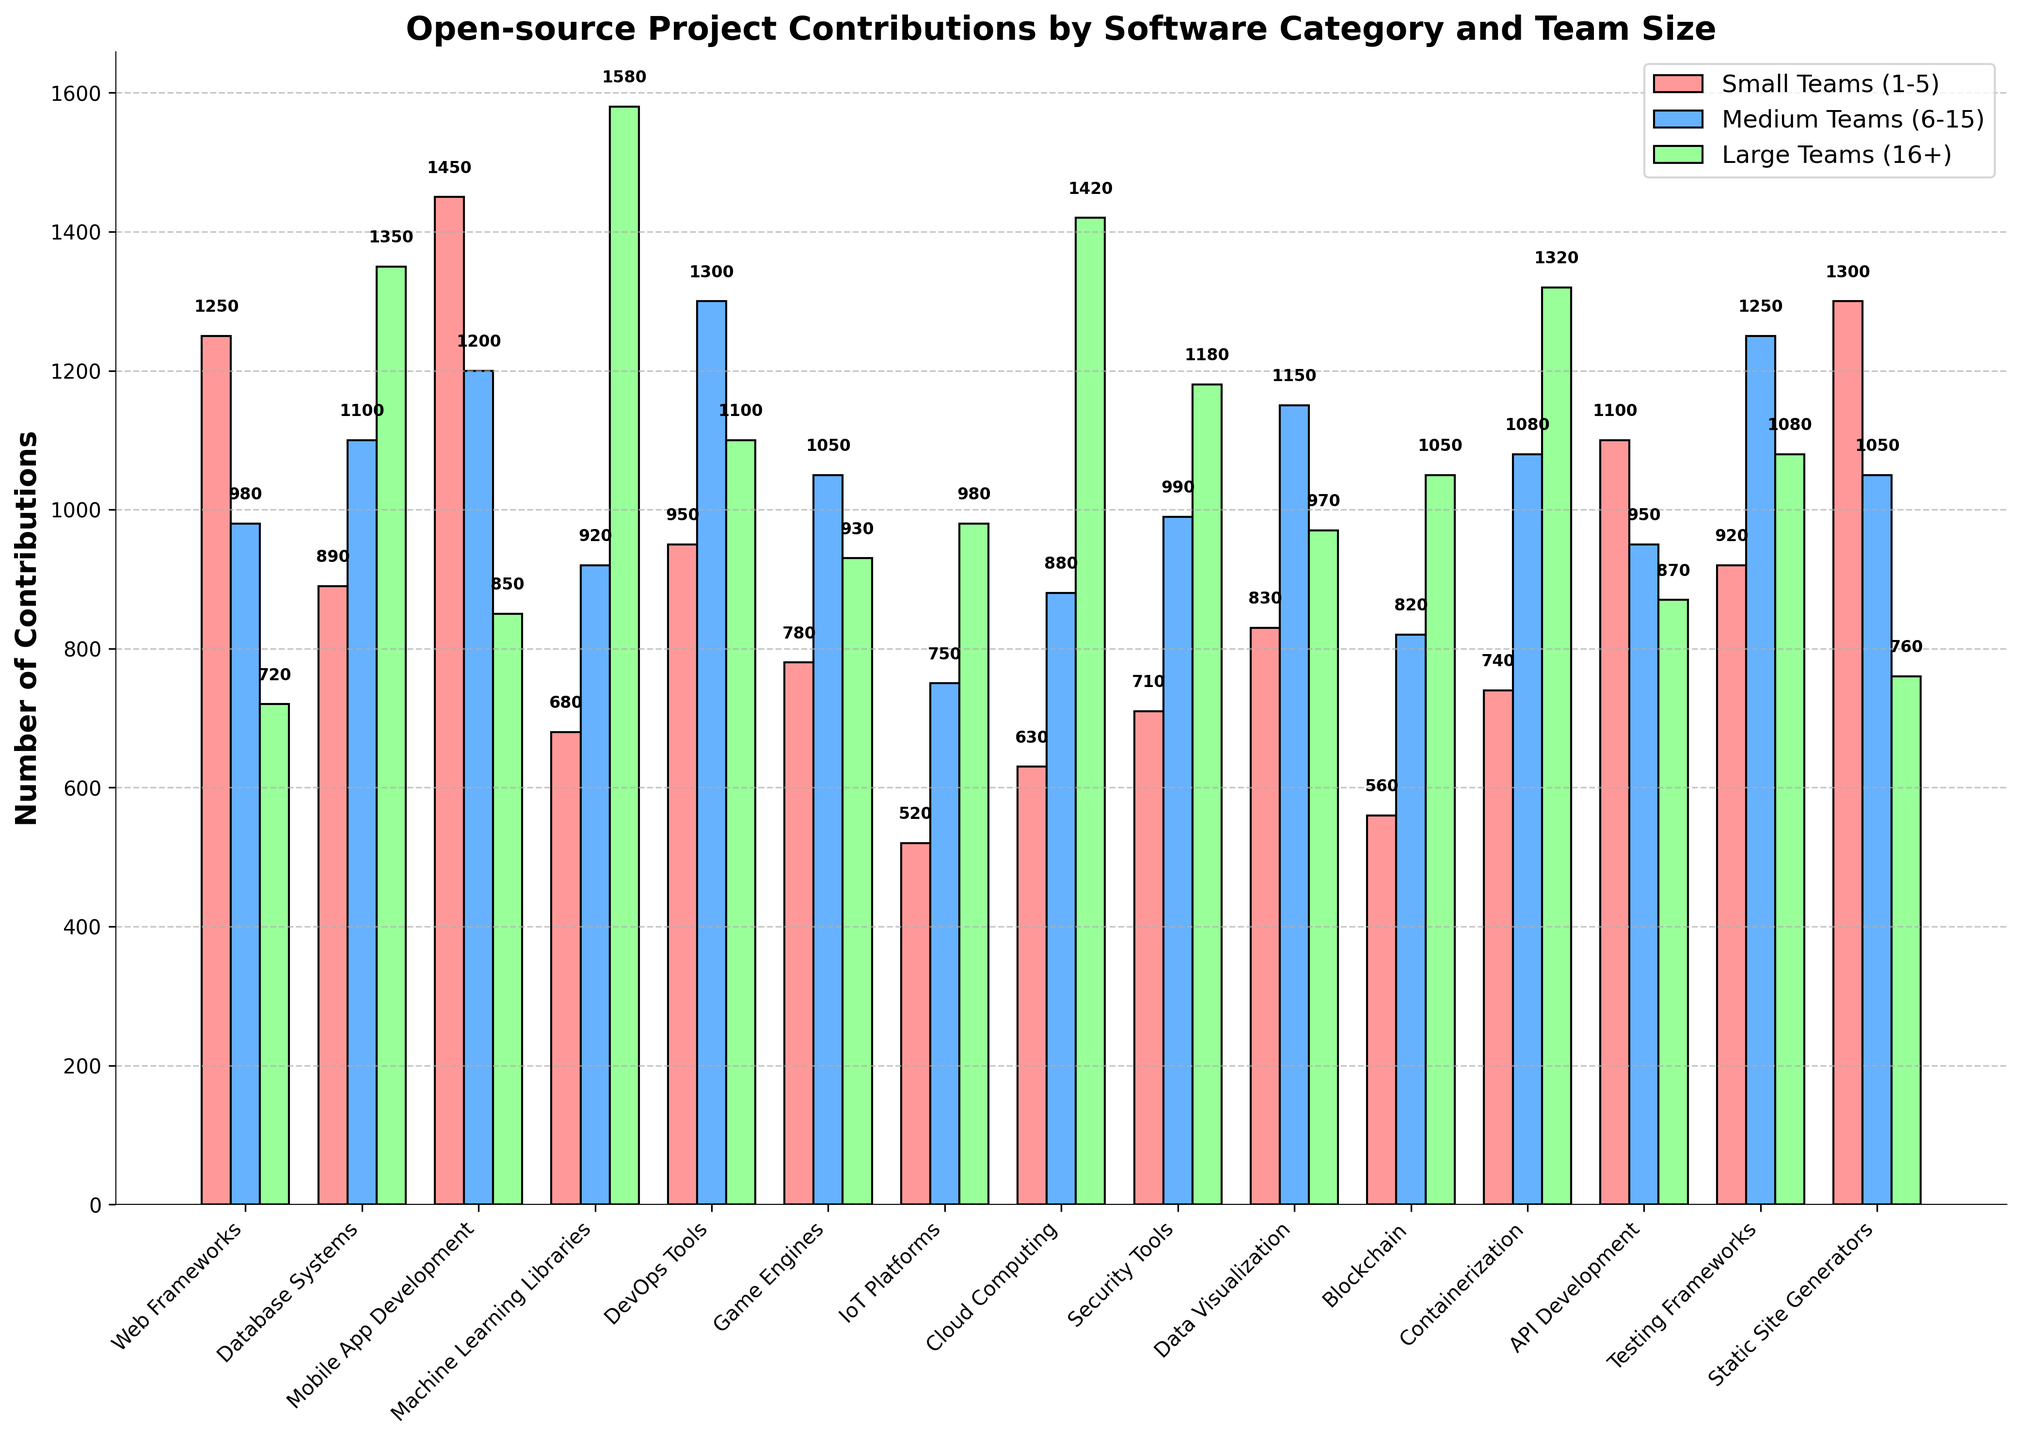Which category received the highest number of contributions from small teams? Look at the bar heights and labels for small teams (red bars) across all categories. The highest red bar corresponds to "Mobile App Development" with 1450 contributions.
Answer: Mobile App Development How many contributions did medium teams make to Web Frameworks and Database Systems combined? Identify the medium teams' (blue bars) contributions for both categories: Web Frameworks (980) and Database Systems (1100). Sum them: 980 + 1100 = 2080.
Answer: 2080 Which team size contributed the most to Machine Learning Libraries? Compare the heights of the three bars for Machine Learning Libraries. The largest bar is the green bar, representing large teams, with 1580 contributions.
Answer: Large Teams Did DevOps Tools receive more contributions from medium teams or large teams? Look at the heights of the blue and green bars for DevOps Tools. Medium teams (blue bar) contributed 1300, while large teams (green bar) contributed 1100.
Answer: Medium Teams What is the difference in contributions between small and large teams for Cloud Computing? Look at the contributions for small teams (630) and large teams (1420) in Cloud Computing. Calculate the difference: 1420 - 630 = 790.
Answer: 790 Which category had the lowest total contributions from all team sizes combined? Sum the contributions for small, medium, and large teams for each category. The smallest combined total is for IoT Platforms: 520 (small) + 750 (medium) + 980 (large) = 2250.
Answer: IoT Platforms What is the average number of contributions made by large teams across all categories? Add contributions from large teams for all categories and divide by the number of categories. List the sums and calculate the average: (720+1350+850+1580+1100+930+980+1420+1180+970+1050+1320+870+1080+760)/15 = 1075.
Answer: 1075 Are there any categories where the contributions from large teams are higher than both small and medium teams? If so, name one. Compare the green bar (large teams) with the red and blue bars (small and medium teams) for each category. Machine Learning Libraries is one example, with contributions of 1580 (large teams) compared to 680 (small) and 920 (medium).
Answer: Machine Learning Libraries How do the total contributions of small and large teams compare for Testing Frameworks? Calculate and compare the total: Small teams (920), Large teams (1080). The difference is 1080 - 920 = 160. Therefore, large teams contributed 160 more.
Answer: 160 Which categories received exactly equal contributions from medium teams? Check all categories for identical heights of blue bars. No categories have exactly equal contributions from medium teams.
Answer: None 